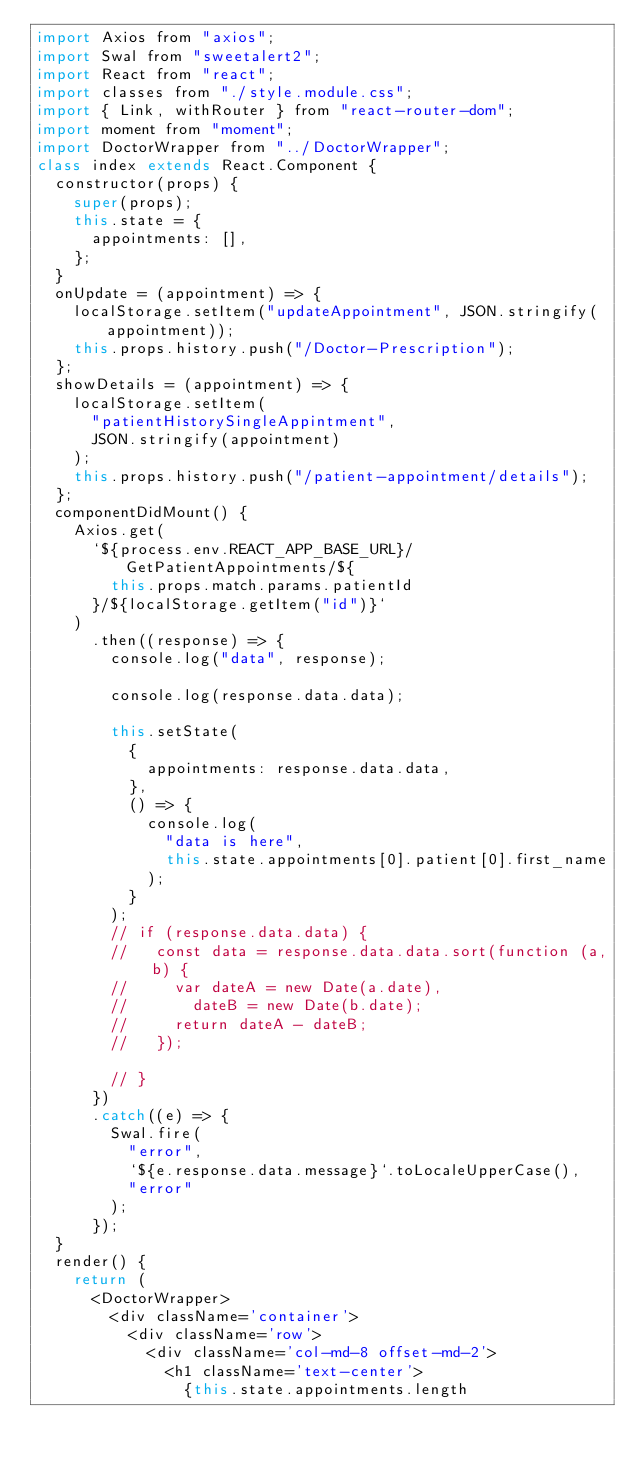Convert code to text. <code><loc_0><loc_0><loc_500><loc_500><_JavaScript_>import Axios from "axios";
import Swal from "sweetalert2";
import React from "react";
import classes from "./style.module.css";
import { Link, withRouter } from "react-router-dom";
import moment from "moment";
import DoctorWrapper from "../DoctorWrapper";
class index extends React.Component {
  constructor(props) {
    super(props);
    this.state = {
      appointments: [],
    };
  }
  onUpdate = (appointment) => {
    localStorage.setItem("updateAppointment", JSON.stringify(appointment));
    this.props.history.push("/Doctor-Prescription");
  };
  showDetails = (appointment) => {
    localStorage.setItem(
      "patientHistorySingleAppintment",
      JSON.stringify(appointment)
    );
    this.props.history.push("/patient-appointment/details");
  };
  componentDidMount() {
    Axios.get(
      `${process.env.REACT_APP_BASE_URL}/GetPatientAppointments/${
        this.props.match.params.patientId
      }/${localStorage.getItem("id")}`
    )
      .then((response) => {
        console.log("data", response);

        console.log(response.data.data);

        this.setState(
          {
            appointments: response.data.data,
          },
          () => {
            console.log(
              "data is here",
              this.state.appointments[0].patient[0].first_name
            );
          }
        );
        // if (response.data.data) {
        //   const data = response.data.data.sort(function (a, b) {
        //     var dateA = new Date(a.date),
        //       dateB = new Date(b.date);
        //     return dateA - dateB;
        //   });

        // }
      })
      .catch((e) => {
        Swal.fire(
          "error",
          `${e.response.data.message}`.toLocaleUpperCase(),
          "error"
        );
      });
  }
  render() {
    return (
      <DoctorWrapper>
        <div className='container'>
          <div className='row'>
            <div className='col-md-8 offset-md-2'>
              <h1 className='text-center'>
                {this.state.appointments.length</code> 